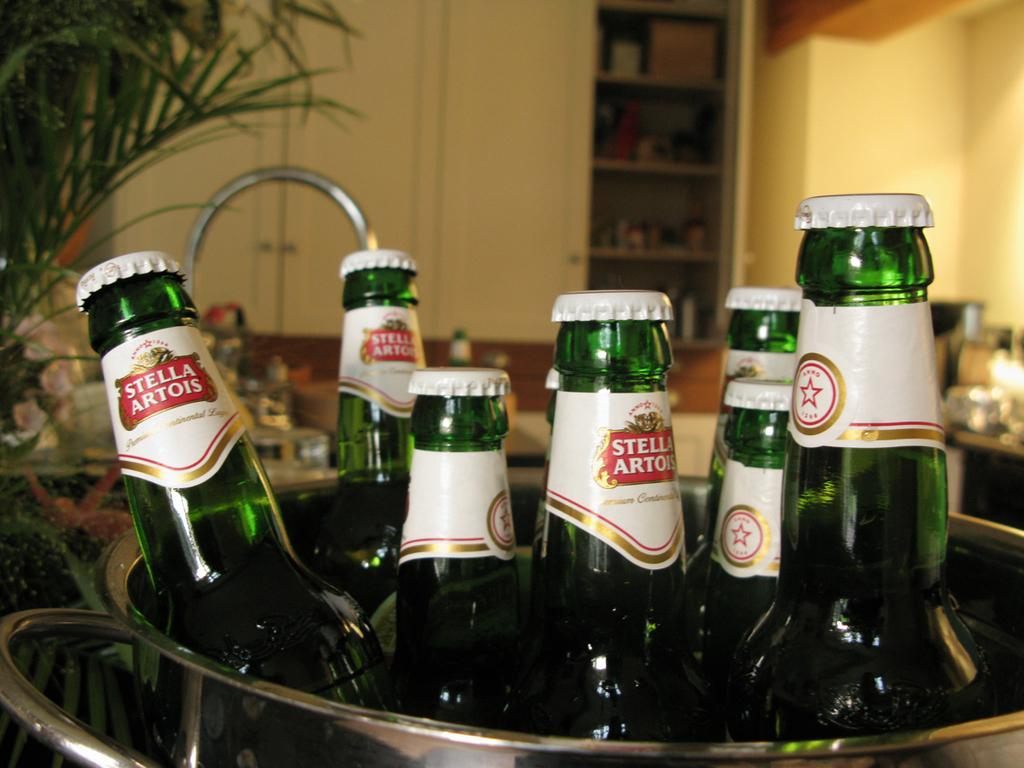<image>
Offer a succinct explanation of the picture presented. A bucket filled with six bottles of Stella Artois beer. 